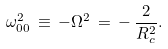<formula> <loc_0><loc_0><loc_500><loc_500>\omega ^ { 2 } _ { 0 0 } \, \equiv \, - \Omega ^ { 2 } \, = \, - \, \frac { 2 } { R _ { c } ^ { 2 } } .</formula> 